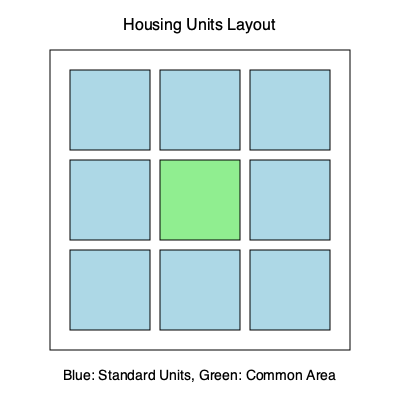In the given layout of temporary worker housing units, what is the ratio of standard housing units to common areas, and how many more standard units could be added while maintaining at least one common area? To solve this spatial intelligence puzzle, let's follow these steps:

1. Count the number of standard housing units (blue squares):
   There are 8 blue squares in the layout.

2. Count the number of common areas (green squares):
   There is 1 green square in the layout.

3. Calculate the ratio of standard units to common areas:
   Ratio = 8:1 or 8/1 = 8

4. Determine how many more standard units could be added:
   - The layout is a 3x3 grid with 9 total spaces
   - Currently, there are 8 standard units and 1 common area
   - To maintain at least one common area, we can't replace the existing one
   - Therefore, no more standard units can be added while keeping at least one common area

The ratio of standard housing units to common areas is 8:1, and 0 more standard units could be added while maintaining at least one common area.
Answer: 8:1 ratio; 0 additional standard units 